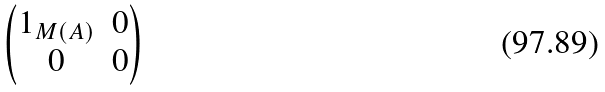Convert formula to latex. <formula><loc_0><loc_0><loc_500><loc_500>\begin{pmatrix} 1 _ { M ( A ) } & 0 \\ 0 & 0 \end{pmatrix}</formula> 